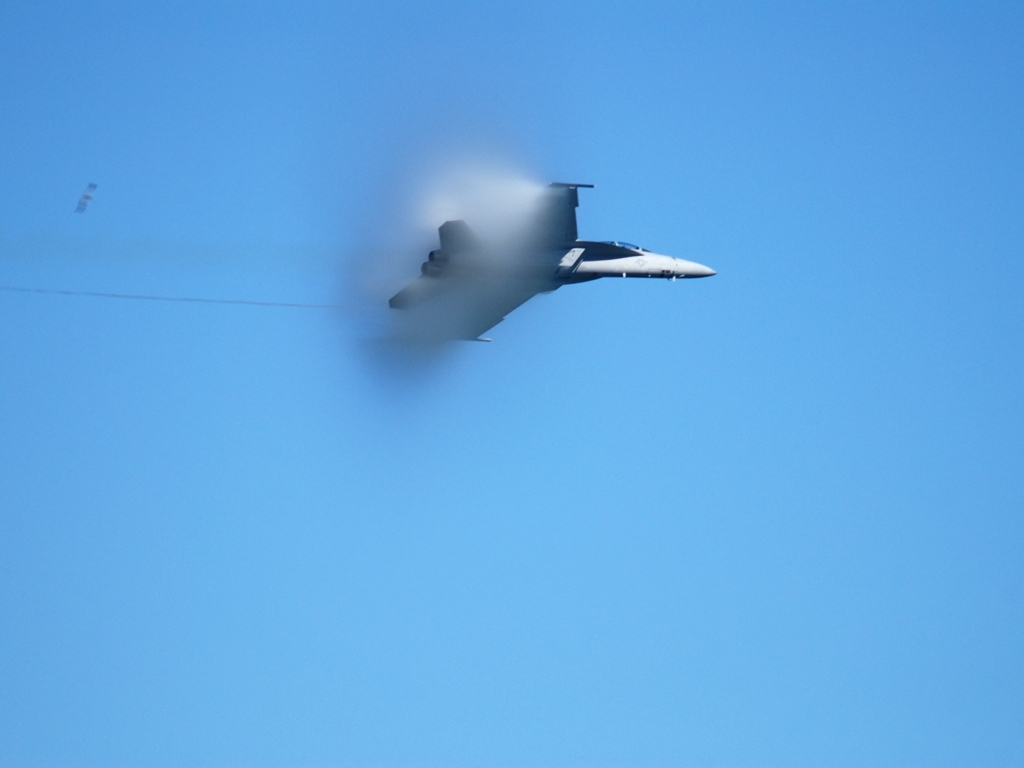Is the saturation level high? The saturation appears to be moderately high, as evidenced by the vivid blue of the sky, which provides a rich backdrop to the subject of the image—a jet aircraft. However, given the haze around the aircraft, the saturation may not be at its maximum, which allows for some natural atmospheric effects to be visible. 